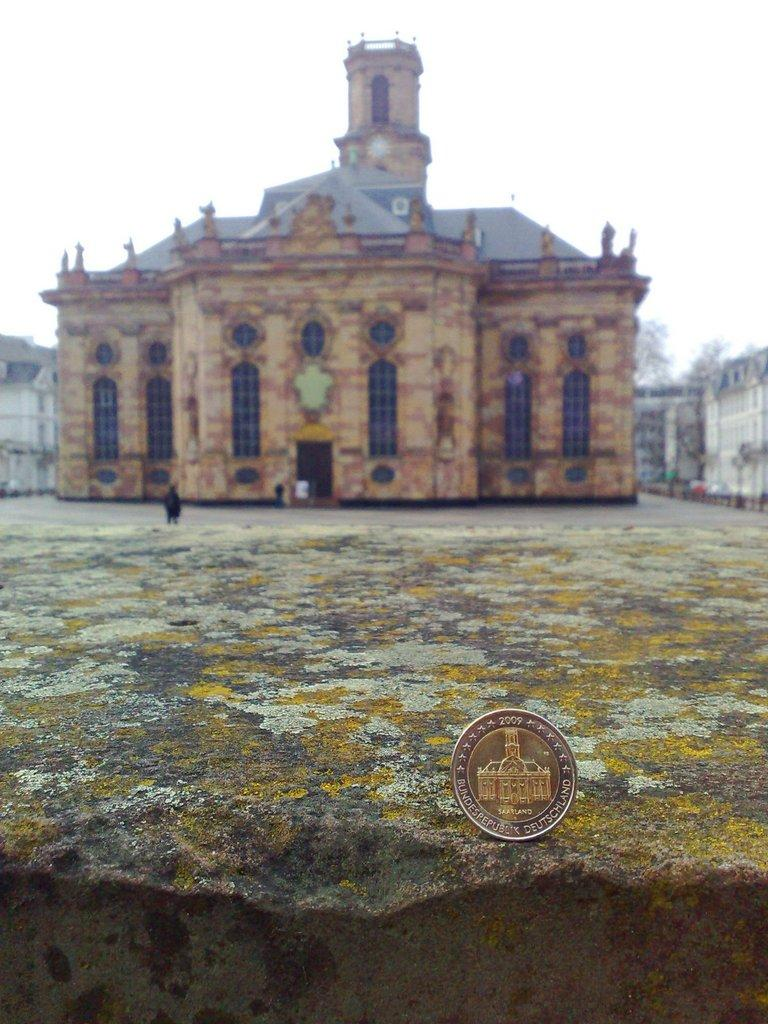What is the main subject of the image? There is a rock in the image. What can be seen in the background of the image? There are buildings and people in the background of the image. What type of carpenter is working on the rock in the image? There is no carpenter present in the image, and the rock is not being worked on. 